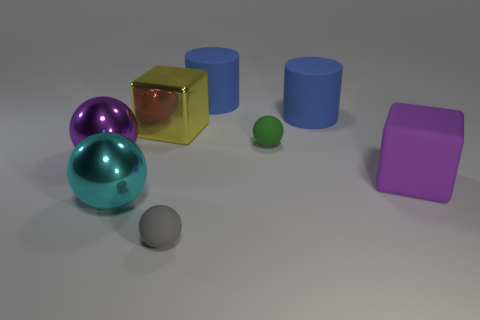Does the green sphere have the same size as the matte object that is in front of the purple cube?
Offer a terse response. Yes. Is the number of small matte things in front of the large cyan metallic thing greater than the number of tiny blue matte balls?
Your answer should be compact. Yes. How many other rubber objects have the same size as the purple rubber object?
Provide a short and direct response. 2. Is the size of the ball that is right of the small gray matte ball the same as the block that is to the left of the gray sphere?
Provide a short and direct response. No. Are there more things behind the green ball than green things in front of the large purple sphere?
Your response must be concise. Yes. What number of blue matte things are the same shape as the purple matte thing?
Give a very brief answer. 0. What material is the thing that is the same size as the green matte sphere?
Make the answer very short. Rubber. Are there any other big things that have the same material as the large cyan object?
Offer a very short reply. Yes. Is the number of blocks in front of the tiny gray rubber thing less than the number of large brown objects?
Provide a succinct answer. No. There is a big blue thing that is left of the matte ball right of the tiny gray sphere; what is its material?
Your answer should be very brief. Rubber. 